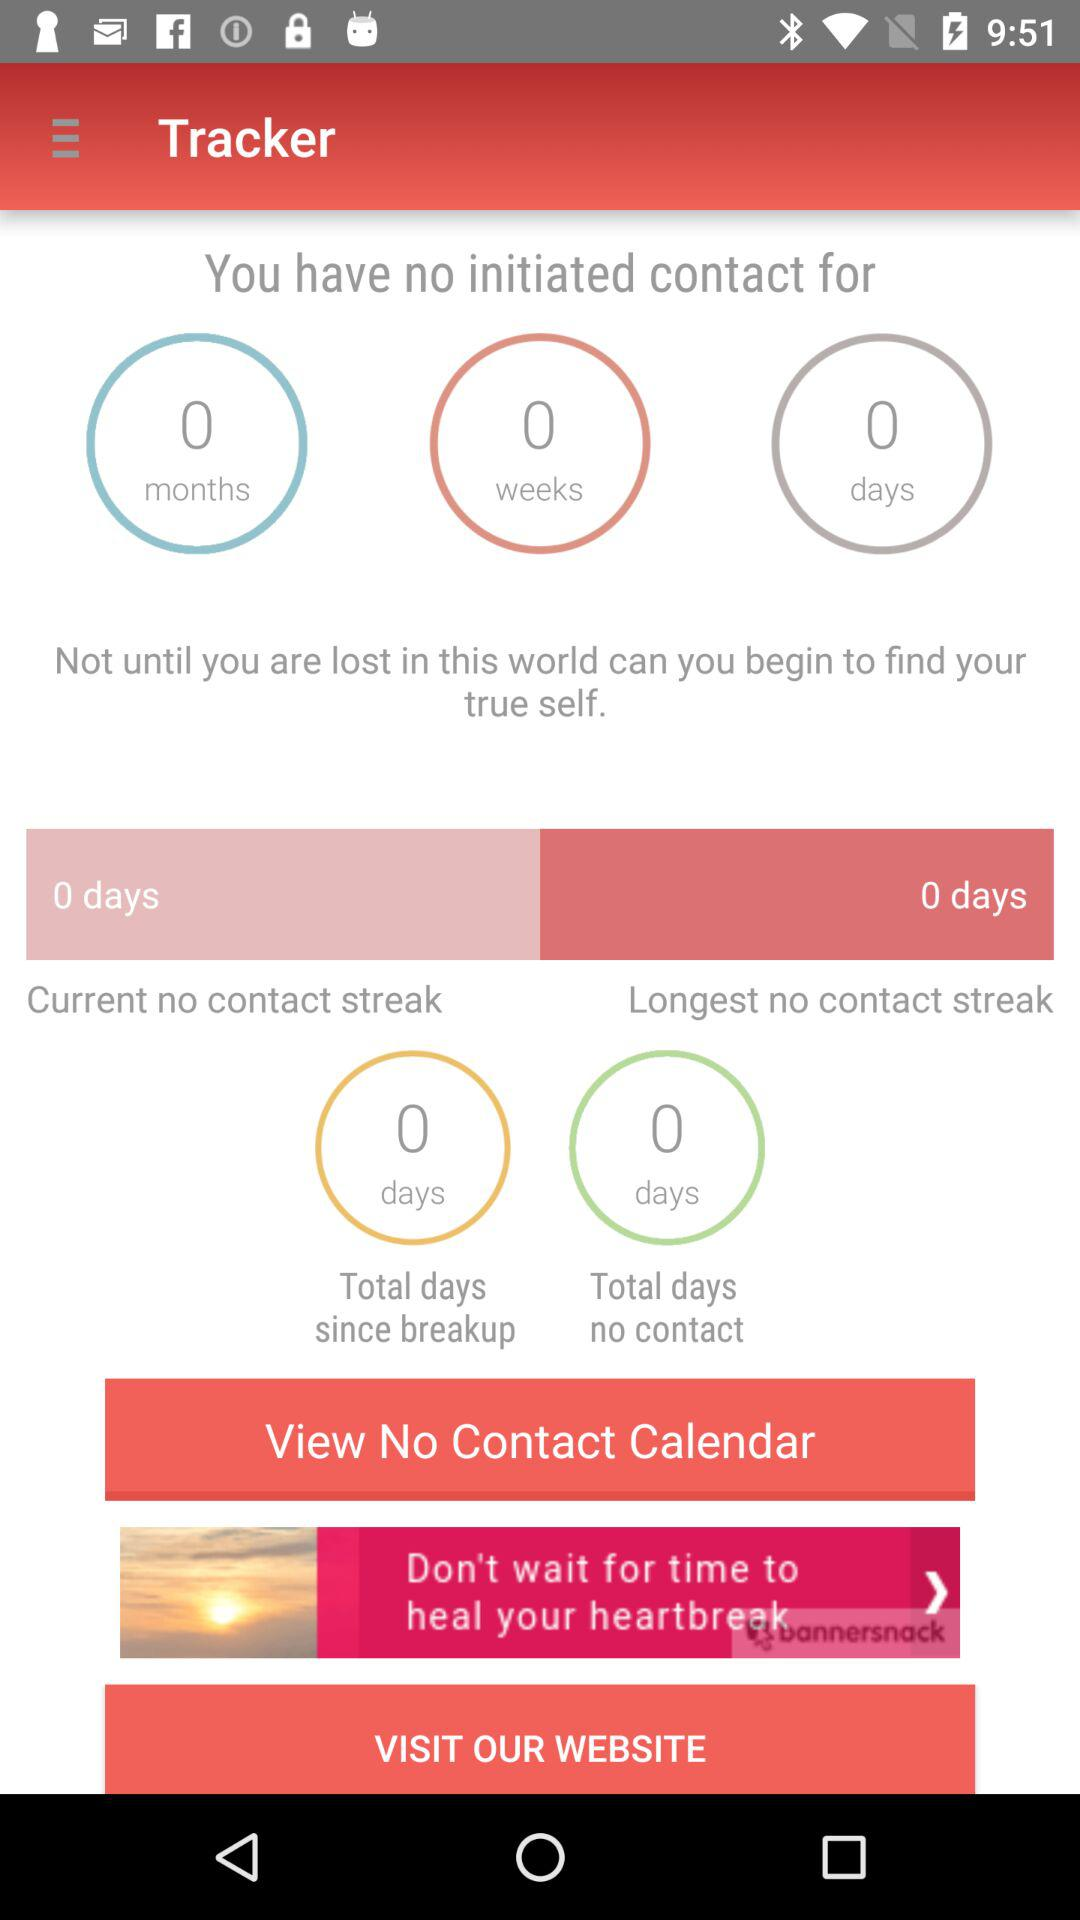Is there any initiated contact? There is no initiated contact. 